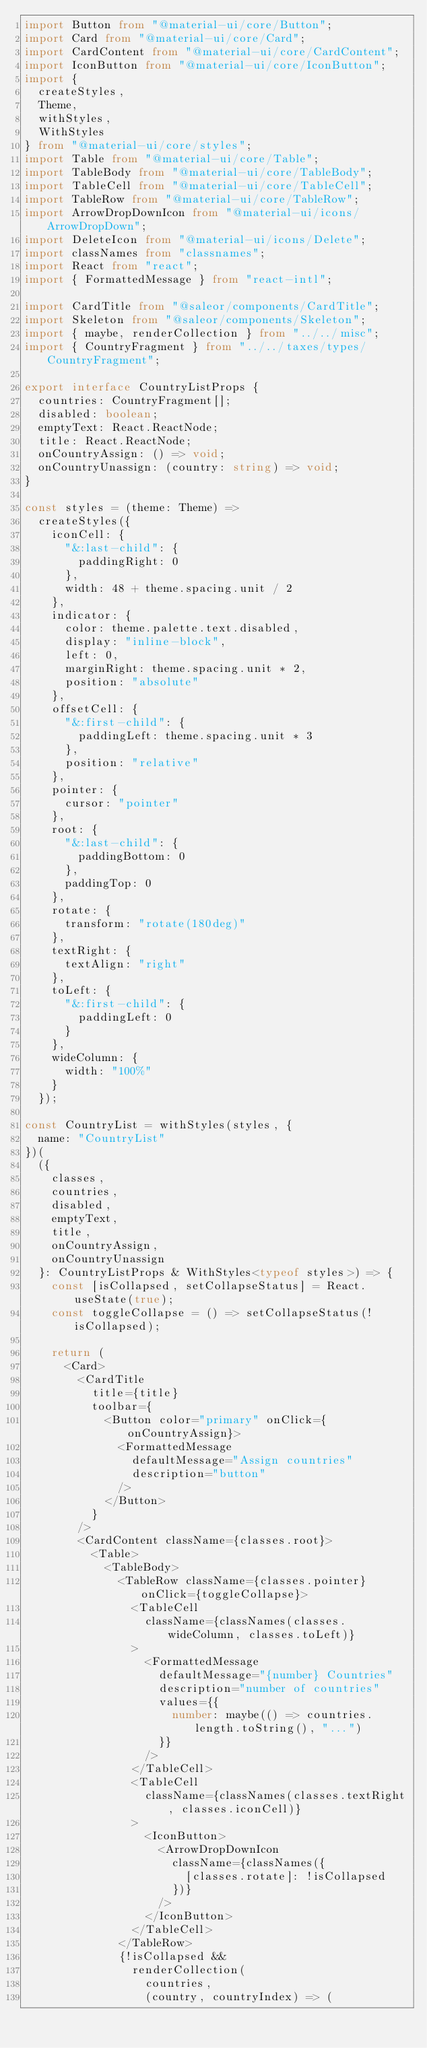Convert code to text. <code><loc_0><loc_0><loc_500><loc_500><_TypeScript_>import Button from "@material-ui/core/Button";
import Card from "@material-ui/core/Card";
import CardContent from "@material-ui/core/CardContent";
import IconButton from "@material-ui/core/IconButton";
import {
  createStyles,
  Theme,
  withStyles,
  WithStyles
} from "@material-ui/core/styles";
import Table from "@material-ui/core/Table";
import TableBody from "@material-ui/core/TableBody";
import TableCell from "@material-ui/core/TableCell";
import TableRow from "@material-ui/core/TableRow";
import ArrowDropDownIcon from "@material-ui/icons/ArrowDropDown";
import DeleteIcon from "@material-ui/icons/Delete";
import classNames from "classnames";
import React from "react";
import { FormattedMessage } from "react-intl";

import CardTitle from "@saleor/components/CardTitle";
import Skeleton from "@saleor/components/Skeleton";
import { maybe, renderCollection } from "../../misc";
import { CountryFragment } from "../../taxes/types/CountryFragment";

export interface CountryListProps {
  countries: CountryFragment[];
  disabled: boolean;
  emptyText: React.ReactNode;
  title: React.ReactNode;
  onCountryAssign: () => void;
  onCountryUnassign: (country: string) => void;
}

const styles = (theme: Theme) =>
  createStyles({
    iconCell: {
      "&:last-child": {
        paddingRight: 0
      },
      width: 48 + theme.spacing.unit / 2
    },
    indicator: {
      color: theme.palette.text.disabled,
      display: "inline-block",
      left: 0,
      marginRight: theme.spacing.unit * 2,
      position: "absolute"
    },
    offsetCell: {
      "&:first-child": {
        paddingLeft: theme.spacing.unit * 3
      },
      position: "relative"
    },
    pointer: {
      cursor: "pointer"
    },
    root: {
      "&:last-child": {
        paddingBottom: 0
      },
      paddingTop: 0
    },
    rotate: {
      transform: "rotate(180deg)"
    },
    textRight: {
      textAlign: "right"
    },
    toLeft: {
      "&:first-child": {
        paddingLeft: 0
      }
    },
    wideColumn: {
      width: "100%"
    }
  });

const CountryList = withStyles(styles, {
  name: "CountryList"
})(
  ({
    classes,
    countries,
    disabled,
    emptyText,
    title,
    onCountryAssign,
    onCountryUnassign
  }: CountryListProps & WithStyles<typeof styles>) => {
    const [isCollapsed, setCollapseStatus] = React.useState(true);
    const toggleCollapse = () => setCollapseStatus(!isCollapsed);

    return (
      <Card>
        <CardTitle
          title={title}
          toolbar={
            <Button color="primary" onClick={onCountryAssign}>
              <FormattedMessage
                defaultMessage="Assign countries"
                description="button"
              />
            </Button>
          }
        />
        <CardContent className={classes.root}>
          <Table>
            <TableBody>
              <TableRow className={classes.pointer} onClick={toggleCollapse}>
                <TableCell
                  className={classNames(classes.wideColumn, classes.toLeft)}
                >
                  <FormattedMessage
                    defaultMessage="{number} Countries"
                    description="number of countries"
                    values={{
                      number: maybe(() => countries.length.toString(), "...")
                    }}
                  />
                </TableCell>
                <TableCell
                  className={classNames(classes.textRight, classes.iconCell)}
                >
                  <IconButton>
                    <ArrowDropDownIcon
                      className={classNames({
                        [classes.rotate]: !isCollapsed
                      })}
                    />
                  </IconButton>
                </TableCell>
              </TableRow>
              {!isCollapsed &&
                renderCollection(
                  countries,
                  (country, countryIndex) => (</code> 